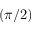Convert formula to latex. <formula><loc_0><loc_0><loc_500><loc_500>( \pi / 2 )</formula> 